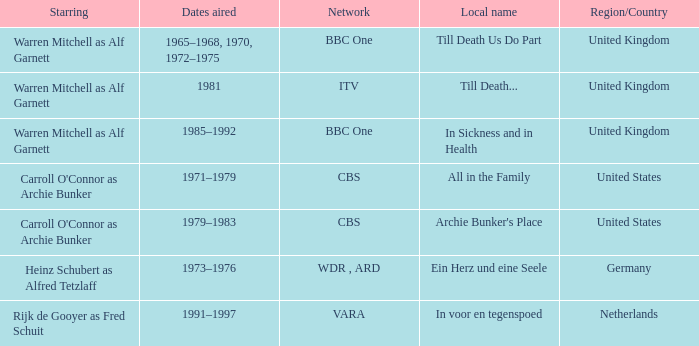What is the local name for the episodes that aired in 1981? Till Death... 